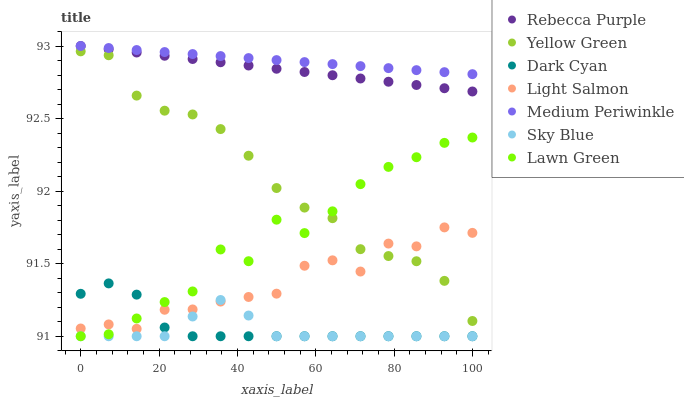Does Sky Blue have the minimum area under the curve?
Answer yes or no. Yes. Does Medium Periwinkle have the maximum area under the curve?
Answer yes or no. Yes. Does Light Salmon have the minimum area under the curve?
Answer yes or no. No. Does Light Salmon have the maximum area under the curve?
Answer yes or no. No. Is Medium Periwinkle the smoothest?
Answer yes or no. Yes. Is Lawn Green the roughest?
Answer yes or no. Yes. Is Light Salmon the smoothest?
Answer yes or no. No. Is Light Salmon the roughest?
Answer yes or no. No. Does Lawn Green have the lowest value?
Answer yes or no. Yes. Does Light Salmon have the lowest value?
Answer yes or no. No. Does Rebecca Purple have the highest value?
Answer yes or no. Yes. Does Light Salmon have the highest value?
Answer yes or no. No. Is Dark Cyan less than Yellow Green?
Answer yes or no. Yes. Is Medium Periwinkle greater than Yellow Green?
Answer yes or no. Yes. Does Sky Blue intersect Light Salmon?
Answer yes or no. Yes. Is Sky Blue less than Light Salmon?
Answer yes or no. No. Is Sky Blue greater than Light Salmon?
Answer yes or no. No. Does Dark Cyan intersect Yellow Green?
Answer yes or no. No. 